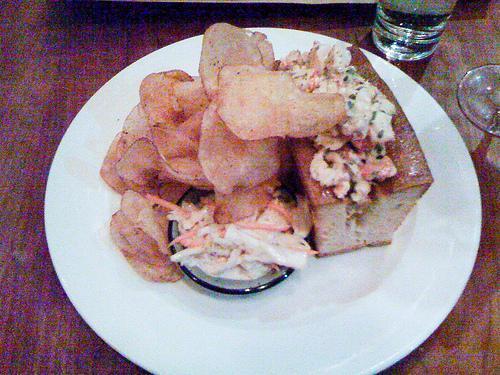How many different food items are on the plate?
Give a very brief answer. 3. 